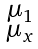Convert formula to latex. <formula><loc_0><loc_0><loc_500><loc_500>\begin{smallmatrix} \mu _ { 1 } \\ \mu _ { x } \end{smallmatrix}</formula> 